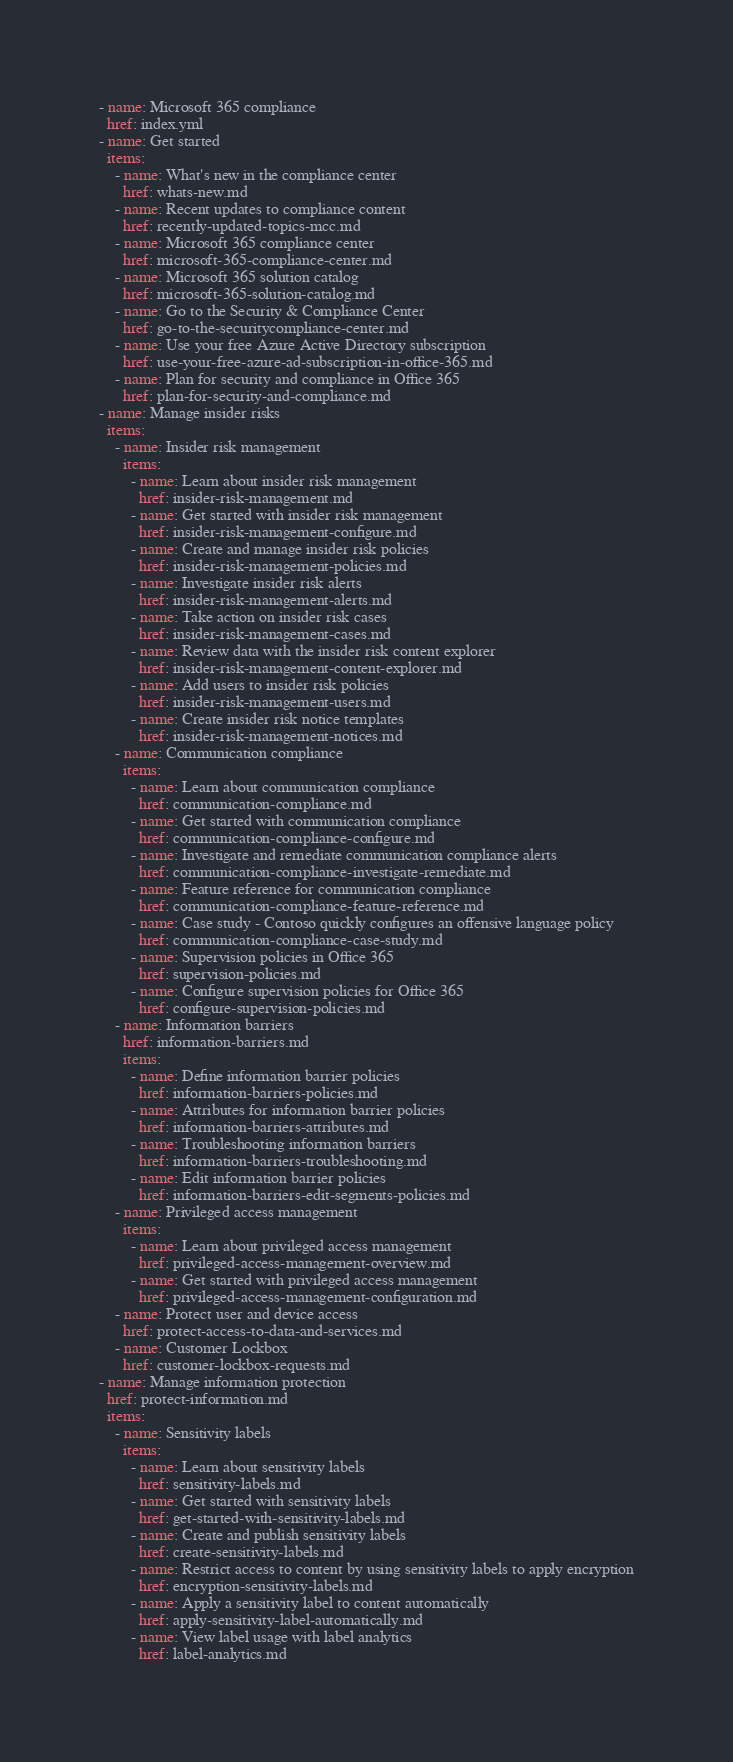Convert code to text. <code><loc_0><loc_0><loc_500><loc_500><_YAML_>- name: Microsoft 365 compliance
  href: index.yml
- name: Get started
  items: 
    - name: What's new in the compliance center
      href: whats-new.md
    - name: Recent updates to compliance content
      href: recently-updated-topics-mcc.md
    - name: Microsoft 365 compliance center
      href: microsoft-365-compliance-center.md
    - name: Microsoft 365 solution catalog
      href: microsoft-365-solution-catalog.md
    - name: Go to the Security & Compliance Center
      href: go-to-the-securitycompliance-center.md
    - name: Use your free Azure Active Directory subscription
      href: use-your-free-azure-ad-subscription-in-office-365.md
    - name: Plan for security and compliance in Office 365
      href: plan-for-security-and-compliance.md
- name: Manage insider risks
  items:
    - name: Insider risk management
      items:
        - name: Learn about insider risk management
          href: insider-risk-management.md
        - name: Get started with insider risk management
          href: insider-risk-management-configure.md
        - name: Create and manage insider risk policies
          href: insider-risk-management-policies.md
        - name: Investigate insider risk alerts
          href: insider-risk-management-alerts.md
        - name: Take action on insider risk cases
          href: insider-risk-management-cases.md
        - name: Review data with the insider risk content explorer
          href: insider-risk-management-content-explorer.md
        - name: Add users to insider risk policies
          href: insider-risk-management-users.md
        - name: Create insider risk notice templates
          href: insider-risk-management-notices.md
    - name: Communication compliance
      items: 
        - name: Learn about communication compliance
          href: communication-compliance.md
        - name: Get started with communication compliance
          href: communication-compliance-configure.md
        - name: Investigate and remediate communication compliance alerts
          href: communication-compliance-investigate-remediate.md
        - name: Feature reference for communication compliance
          href: communication-compliance-feature-reference.md
        - name: Case study - Contoso quickly configures an offensive language policy 
          href: communication-compliance-case-study.md
        - name: Supervision policies in Office 365
          href: supervision-policies.md
        - name: Configure supervision policies for Office 365
          href: configure-supervision-policies.md
    - name: Information barriers
      href: information-barriers.md
      items: 
        - name: Define information barrier policies
          href: information-barriers-policies.md
        - name: Attributes for information barrier policies
          href: information-barriers-attributes.md
        - name: Troubleshooting information barriers
          href: information-barriers-troubleshooting.md
        - name: Edit information barrier policies
          href: information-barriers-edit-segments-policies.md
    - name: Privileged access management
      items: 
        - name: Learn about privileged access management
          href: privileged-access-management-overview.md
        - name: Get started with privileged access management
          href: privileged-access-management-configuration.md
    - name: Protect user and device access
      href: protect-access-to-data-and-services.md
    - name: Customer Lockbox
      href: customer-lockbox-requests.md
- name: Manage information protection
  href: protect-information.md
  items: 
    - name: Sensitivity labels
      items:
        - name: Learn about sensitivity labels
          href: sensitivity-labels.md
        - name: Get started with sensitivity labels
          href: get-started-with-sensitivity-labels.md
        - name: Create and publish sensitivity labels
          href: create-sensitivity-labels.md
        - name: Restrict access to content by using sensitivity labels to apply encryption
          href: encryption-sensitivity-labels.md
        - name: Apply a sensitivity label to content automatically
          href: apply-sensitivity-label-automatically.md
        - name: View label usage with label analytics
          href: label-analytics.md</code> 